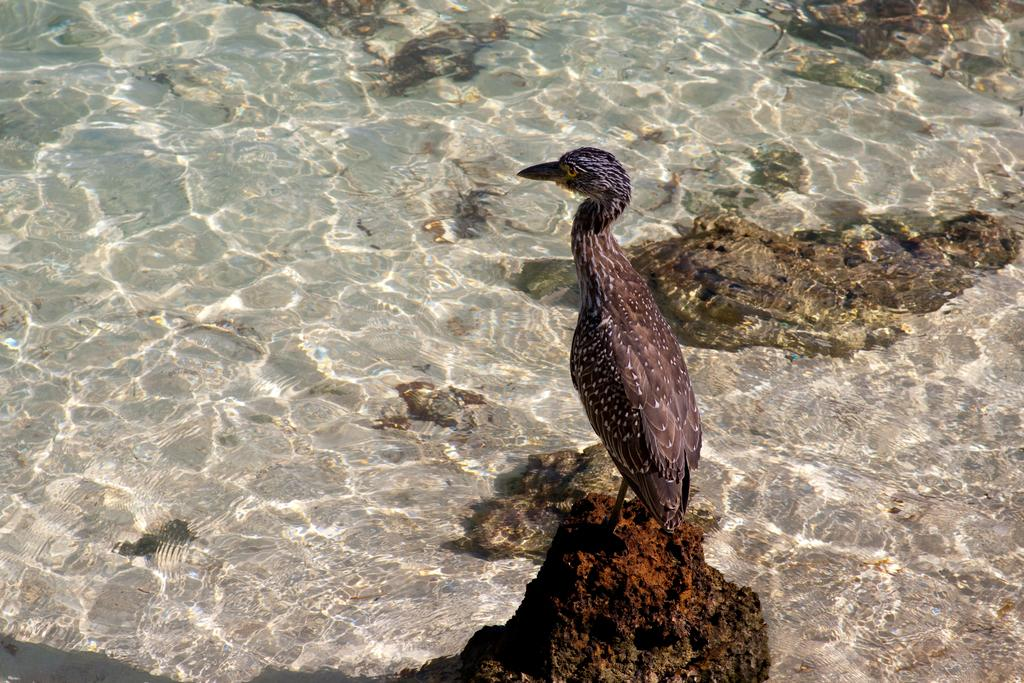What type of animal can be seen in the image? There is a bird in the image. What other objects or features are present in the image? There are rocks and water visible in the image. Where is the house located in the image? There is no house present in the image. What type of fact can be learned from the image? The image does not present any specific facts; it simply shows a bird, rocks, and water. 